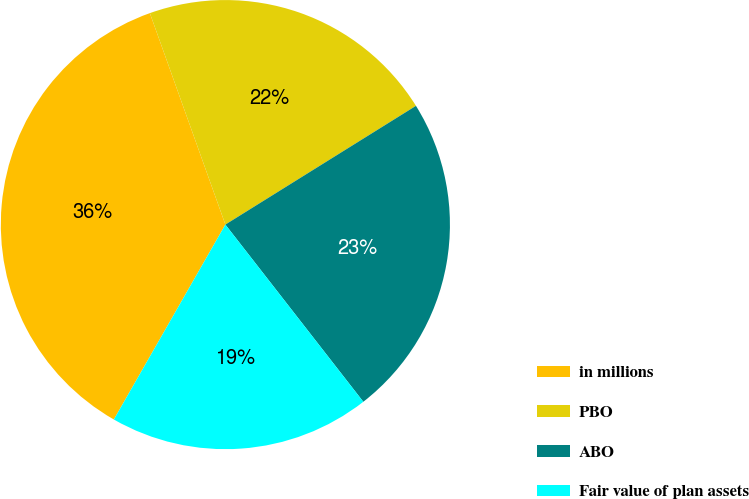Convert chart to OTSL. <chart><loc_0><loc_0><loc_500><loc_500><pie_chart><fcel>in millions<fcel>PBO<fcel>ABO<fcel>Fair value of plan assets<nl><fcel>36.27%<fcel>21.59%<fcel>23.34%<fcel>18.8%<nl></chart> 